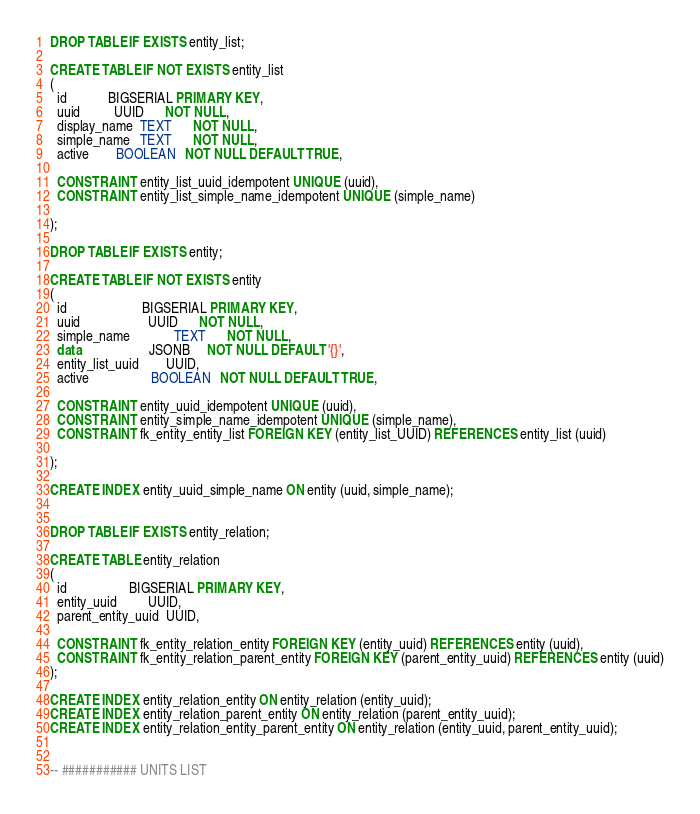<code> <loc_0><loc_0><loc_500><loc_500><_SQL_>DROP TABLE IF EXISTS entity_list;

CREATE TABLE IF NOT EXISTS entity_list
(
  id            BIGSERIAL PRIMARY KEY,
  uuid          UUID      NOT NULL,
  display_name  TEXT      NOT NULL,
  simple_name   TEXT      NOT NULL,
  active        BOOLEAN   NOT NULL DEFAULT TRUE,

  CONSTRAINT entity_list_uuid_idempotent UNIQUE (uuid),
  CONSTRAINT entity_list_simple_name_idempotent UNIQUE (simple_name)

);

DROP TABLE IF EXISTS entity;

CREATE TABLE IF NOT EXISTS entity
(
  id                      BIGSERIAL PRIMARY KEY,
  uuid                    UUID      NOT NULL,
  simple_name             TEXT      NOT NULL,
  data                    JSONB     NOT NULL DEFAULT '{}',
  entity_list_uuid        UUID,
  active                  BOOLEAN   NOT NULL DEFAULT TRUE,

  CONSTRAINT entity_uuid_idempotent UNIQUE (uuid),
  CONSTRAINT entity_simple_name_idempotent UNIQUE (simple_name),
  CONSTRAINT fk_entity_entity_list FOREIGN KEY (entity_list_UUID) REFERENCES entity_list (uuid)

);

CREATE INDEX entity_uuid_simple_name ON entity (uuid, simple_name);


DROP TABLE IF EXISTS entity_relation;

CREATE TABLE entity_relation
(
  id                  BIGSERIAL PRIMARY KEY,
  entity_uuid         UUID,
  parent_entity_uuid  UUID,

  CONSTRAINT fk_entity_relation_entity FOREIGN KEY (entity_uuid) REFERENCES entity (uuid),
  CONSTRAINT fk_entity_relation_parent_entity FOREIGN KEY (parent_entity_uuid) REFERENCES entity (uuid)
);

CREATE INDEX entity_relation_entity ON entity_relation (entity_uuid);
CREATE INDEX entity_relation_parent_entity ON entity_relation (parent_entity_uuid);
CREATE INDEX entity_relation_entity_parent_entity ON entity_relation (entity_uuid, parent_entity_uuid);


-- ########### UNITS LIST</code> 